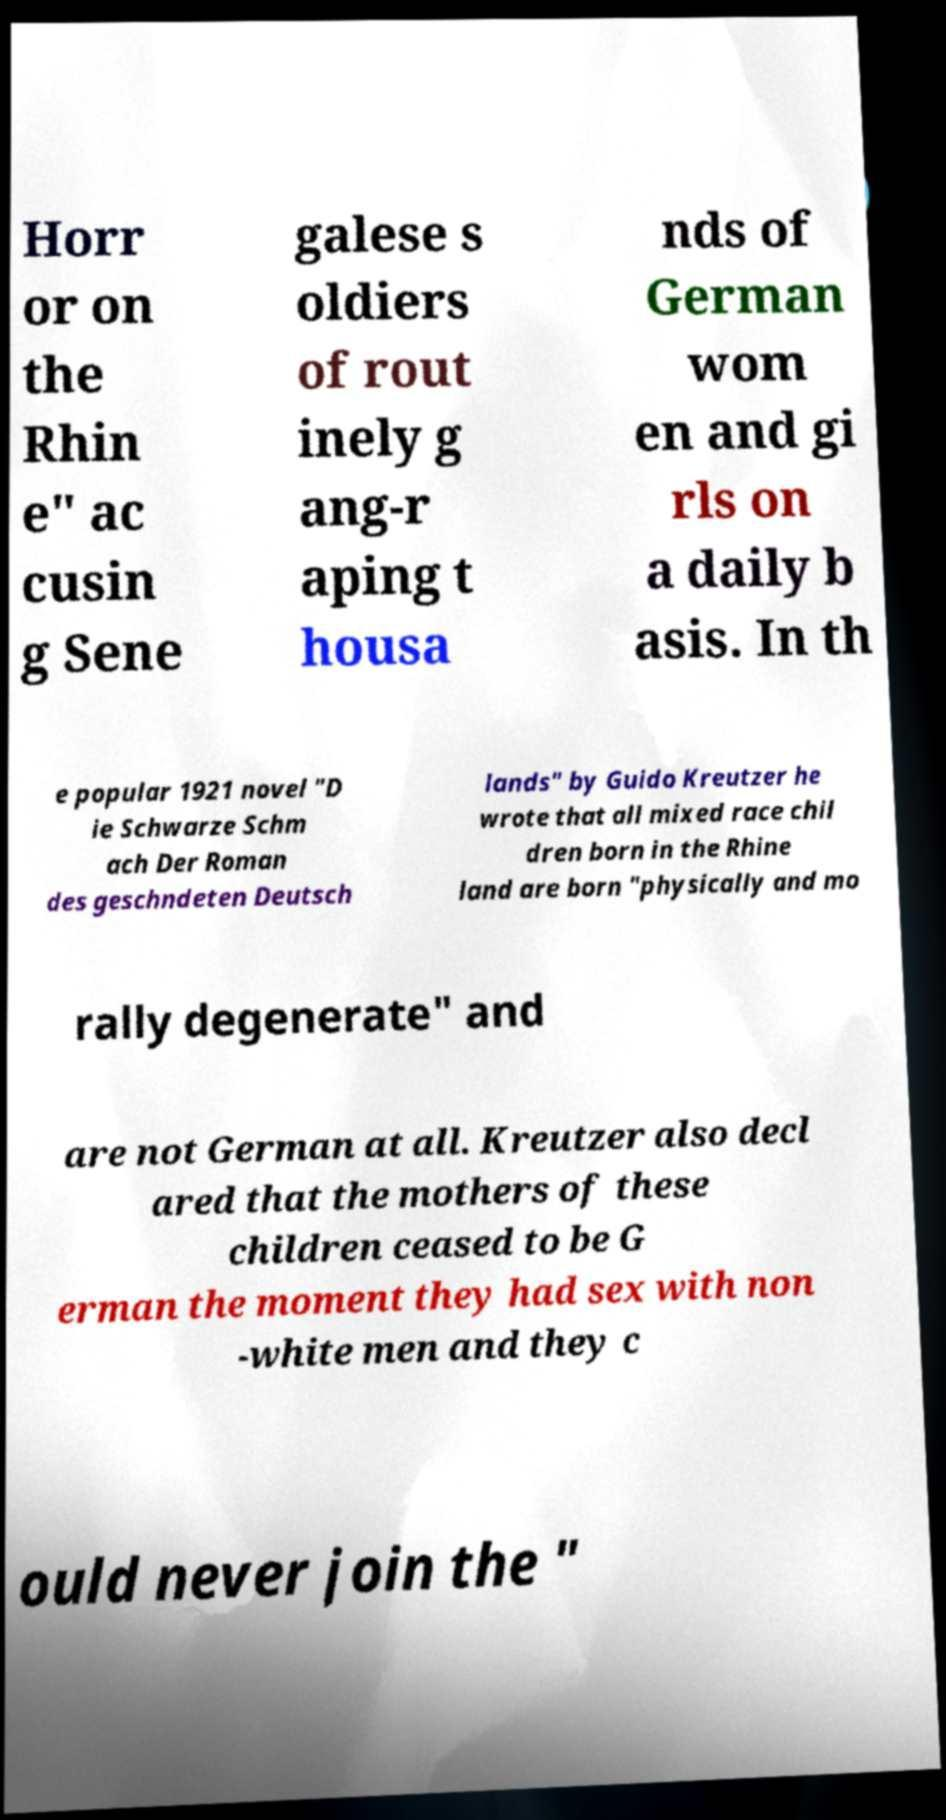Please identify and transcribe the text found in this image. Horr or on the Rhin e" ac cusin g Sene galese s oldiers of rout inely g ang-r aping t housa nds of German wom en and gi rls on a daily b asis. In th e popular 1921 novel "D ie Schwarze Schm ach Der Roman des geschndeten Deutsch lands" by Guido Kreutzer he wrote that all mixed race chil dren born in the Rhine land are born "physically and mo rally degenerate" and are not German at all. Kreutzer also decl ared that the mothers of these children ceased to be G erman the moment they had sex with non -white men and they c ould never join the " 